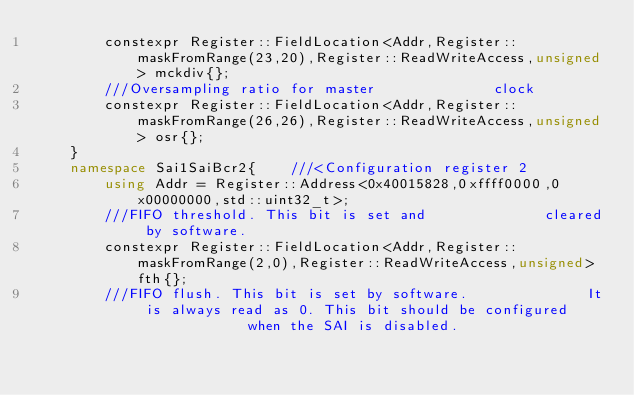Convert code to text. <code><loc_0><loc_0><loc_500><loc_500><_C++_>        constexpr Register::FieldLocation<Addr,Register::maskFromRange(23,20),Register::ReadWriteAccess,unsigned> mckdiv{}; 
        ///Oversampling ratio for master              clock
        constexpr Register::FieldLocation<Addr,Register::maskFromRange(26,26),Register::ReadWriteAccess,unsigned> osr{}; 
    }
    namespace Sai1SaiBcr2{    ///<Configuration register 2
        using Addr = Register::Address<0x40015828,0xffff0000,0x00000000,std::uint32_t>;
        ///FIFO threshold. This bit is set and              cleared by software.
        constexpr Register::FieldLocation<Addr,Register::maskFromRange(2,0),Register::ReadWriteAccess,unsigned> fth{}; 
        ///FIFO flush. This bit is set by software.              It is always read as 0. This bit should be configured              when the SAI is disabled.</code> 